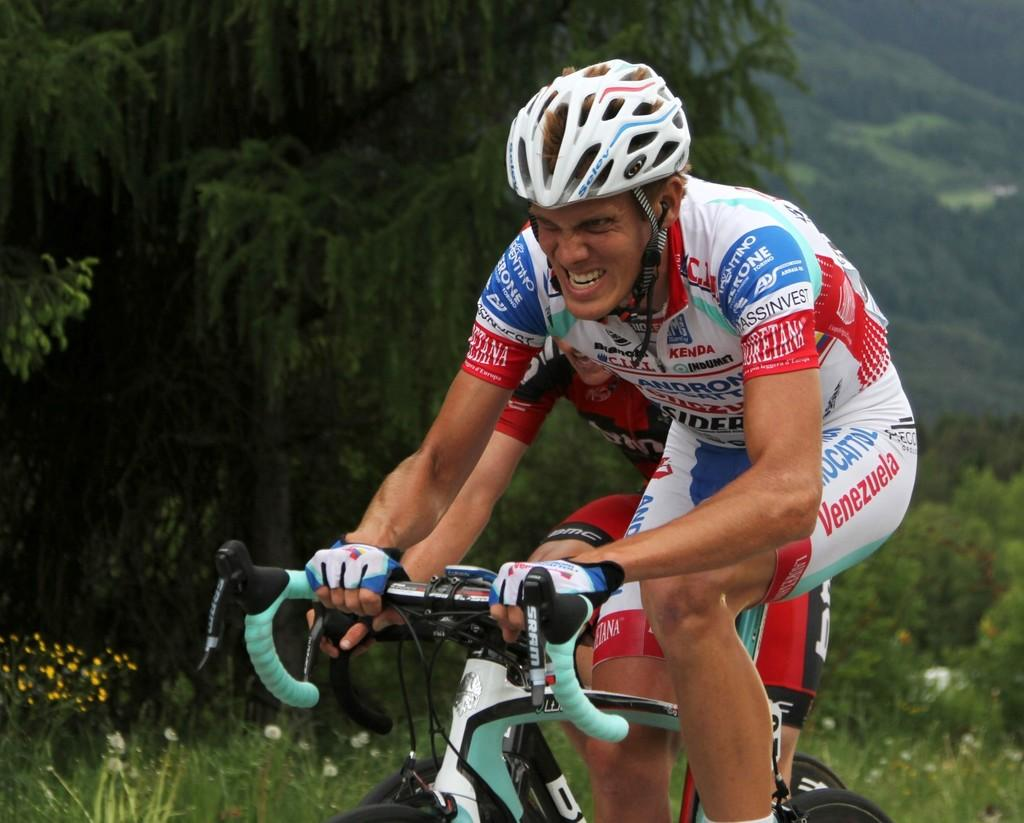What are the people in the image doing? The people in the image are riding bicycles. Where are the people riding bicycles located in the image? The people riding bicycles are in the center of the image. What can be seen in the background of the image? There are trees and plants in the background of the image. What type of crime is being committed in the image? There is no crime being committed in the image; it features people riding bicycles in a natural setting. What is the growth rate of the plants in the image? The growth rate of the plants cannot be determined from the image, as it only provides a snapshot of the scene. 